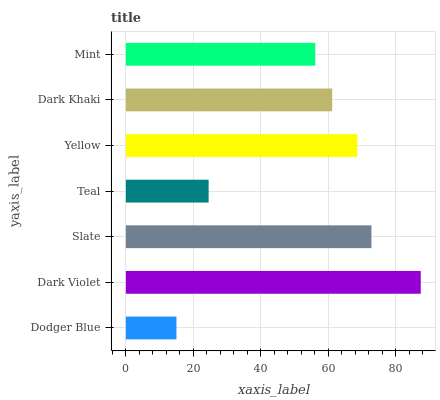Is Dodger Blue the minimum?
Answer yes or no. Yes. Is Dark Violet the maximum?
Answer yes or no. Yes. Is Slate the minimum?
Answer yes or no. No. Is Slate the maximum?
Answer yes or no. No. Is Dark Violet greater than Slate?
Answer yes or no. Yes. Is Slate less than Dark Violet?
Answer yes or no. Yes. Is Slate greater than Dark Violet?
Answer yes or no. No. Is Dark Violet less than Slate?
Answer yes or no. No. Is Dark Khaki the high median?
Answer yes or no. Yes. Is Dark Khaki the low median?
Answer yes or no. Yes. Is Dodger Blue the high median?
Answer yes or no. No. Is Mint the low median?
Answer yes or no. No. 